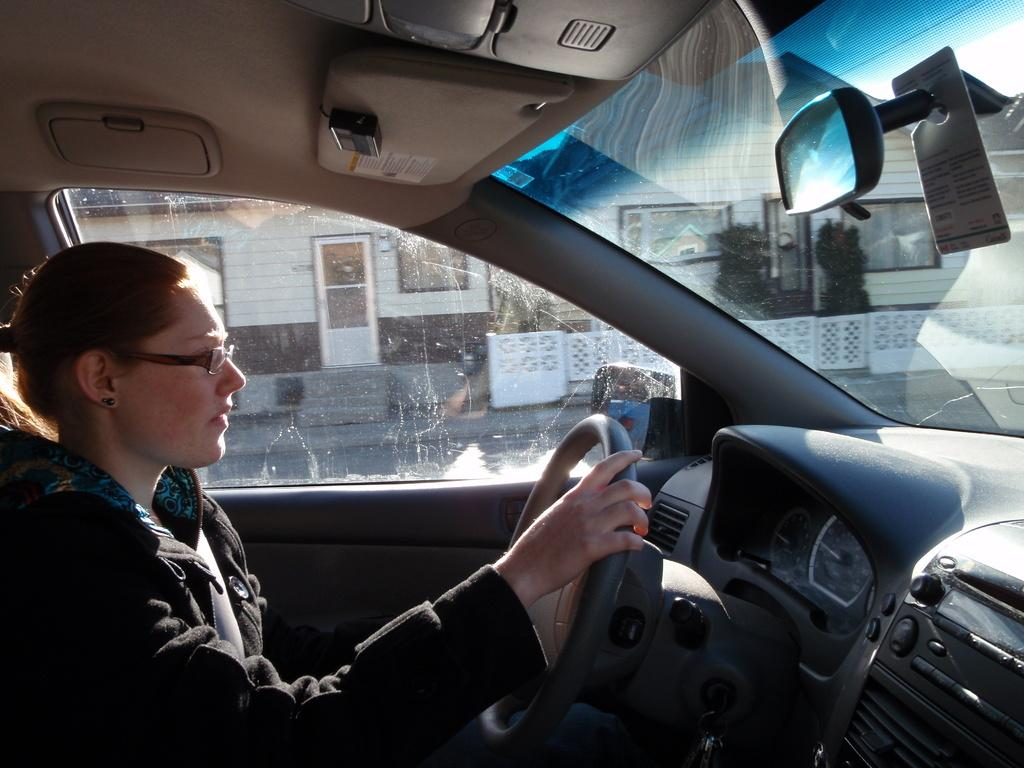What is the setting of the image? The image is taken inside a car. Who is present in the car in the image? There is a lady in the car. What is the lady doing in the image? The lady is driving the car. Can you see the lady's grandmother in the image? There is no mention of a grandmother in the image, and therefore it cannot be determined if she is present. What caused the lady to start driving the car in the image? The image does not provide information about the cause or reason for the lady to start driving the car. 